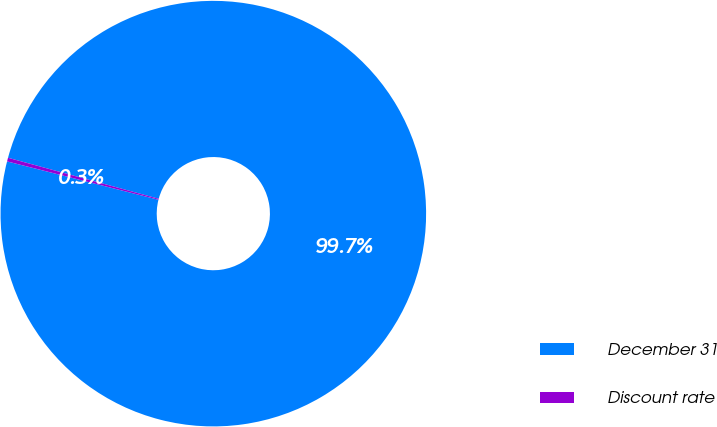Convert chart. <chart><loc_0><loc_0><loc_500><loc_500><pie_chart><fcel>December 31<fcel>Discount rate<nl><fcel>99.72%<fcel>0.28%<nl></chart> 